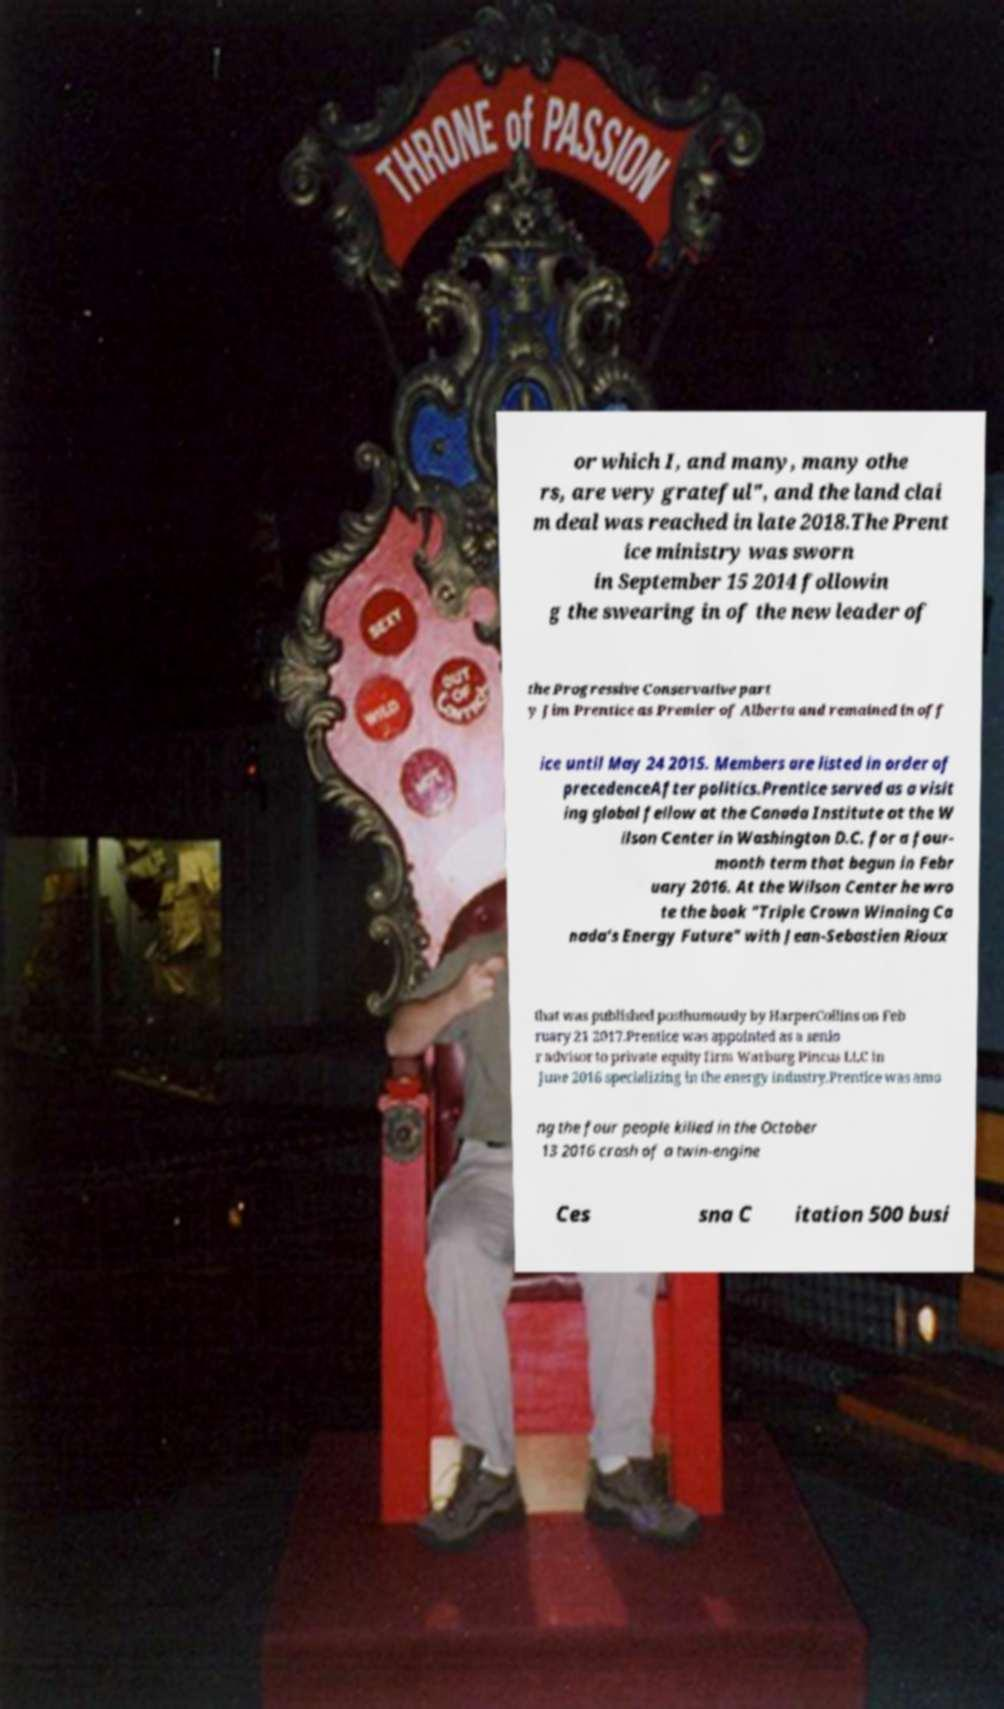Can you accurately transcribe the text from the provided image for me? or which I, and many, many othe rs, are very grateful", and the land clai m deal was reached in late 2018.The Prent ice ministry was sworn in September 15 2014 followin g the swearing in of the new leader of the Progressive Conservative part y Jim Prentice as Premier of Alberta and remained in off ice until May 24 2015. Members are listed in order of precedenceAfter politics.Prentice served as a visit ing global fellow at the Canada Institute at the W ilson Center in Washington D.C. for a four- month term that begun in Febr uary 2016. At the Wilson Center he wro te the book "Triple Crown Winning Ca nada’s Energy Future" with Jean-Sebastien Rioux that was published posthumously by HarperCollins on Feb ruary 21 2017.Prentice was appointed as a senio r advisor to private equity firm Warburg Pincus LLC in June 2016 specializing in the energy industry.Prentice was amo ng the four people killed in the October 13 2016 crash of a twin-engine Ces sna C itation 500 busi 